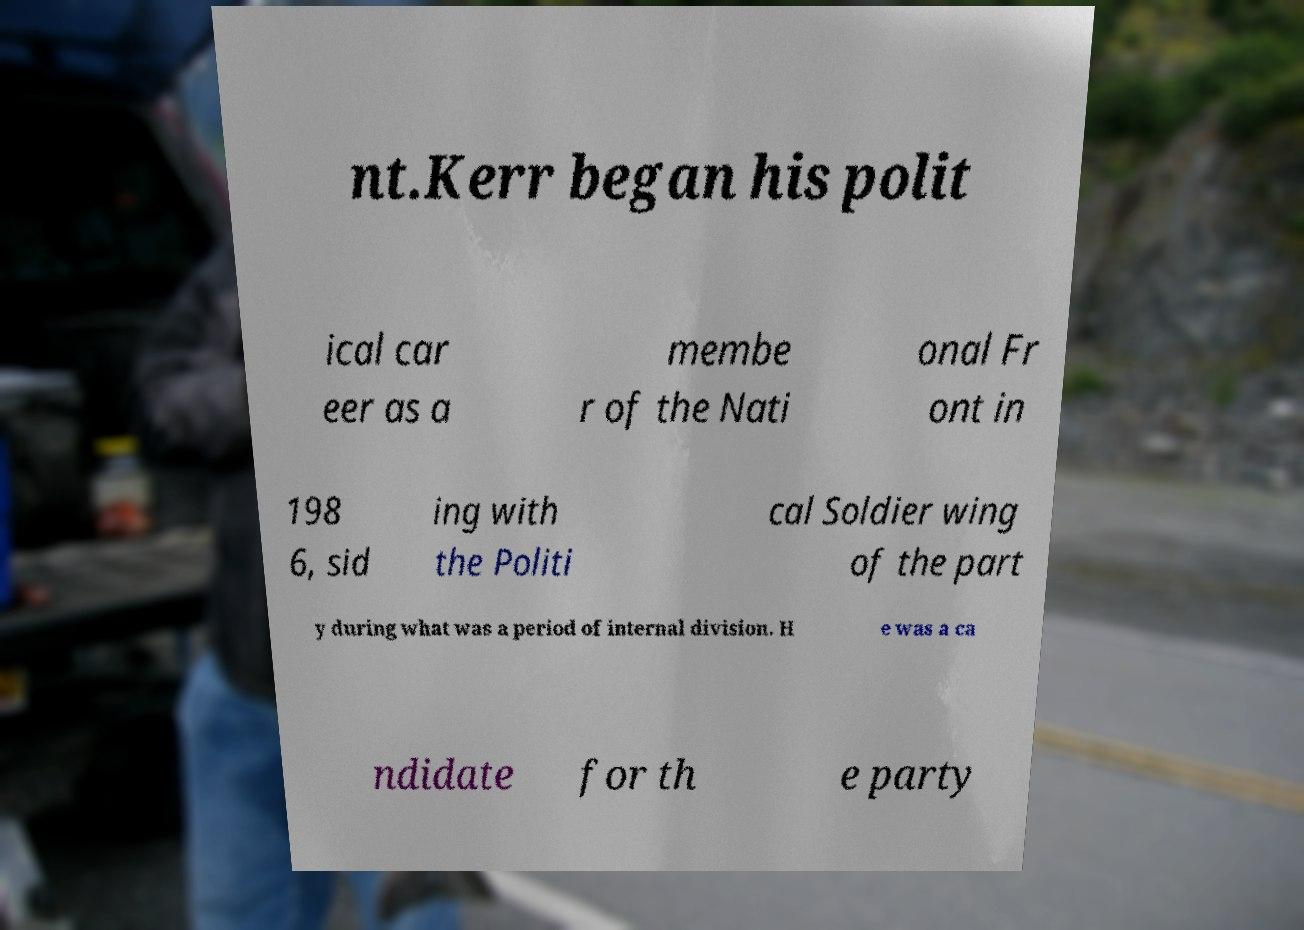Please read and relay the text visible in this image. What does it say? nt.Kerr began his polit ical car eer as a membe r of the Nati onal Fr ont in 198 6, sid ing with the Politi cal Soldier wing of the part y during what was a period of internal division. H e was a ca ndidate for th e party 